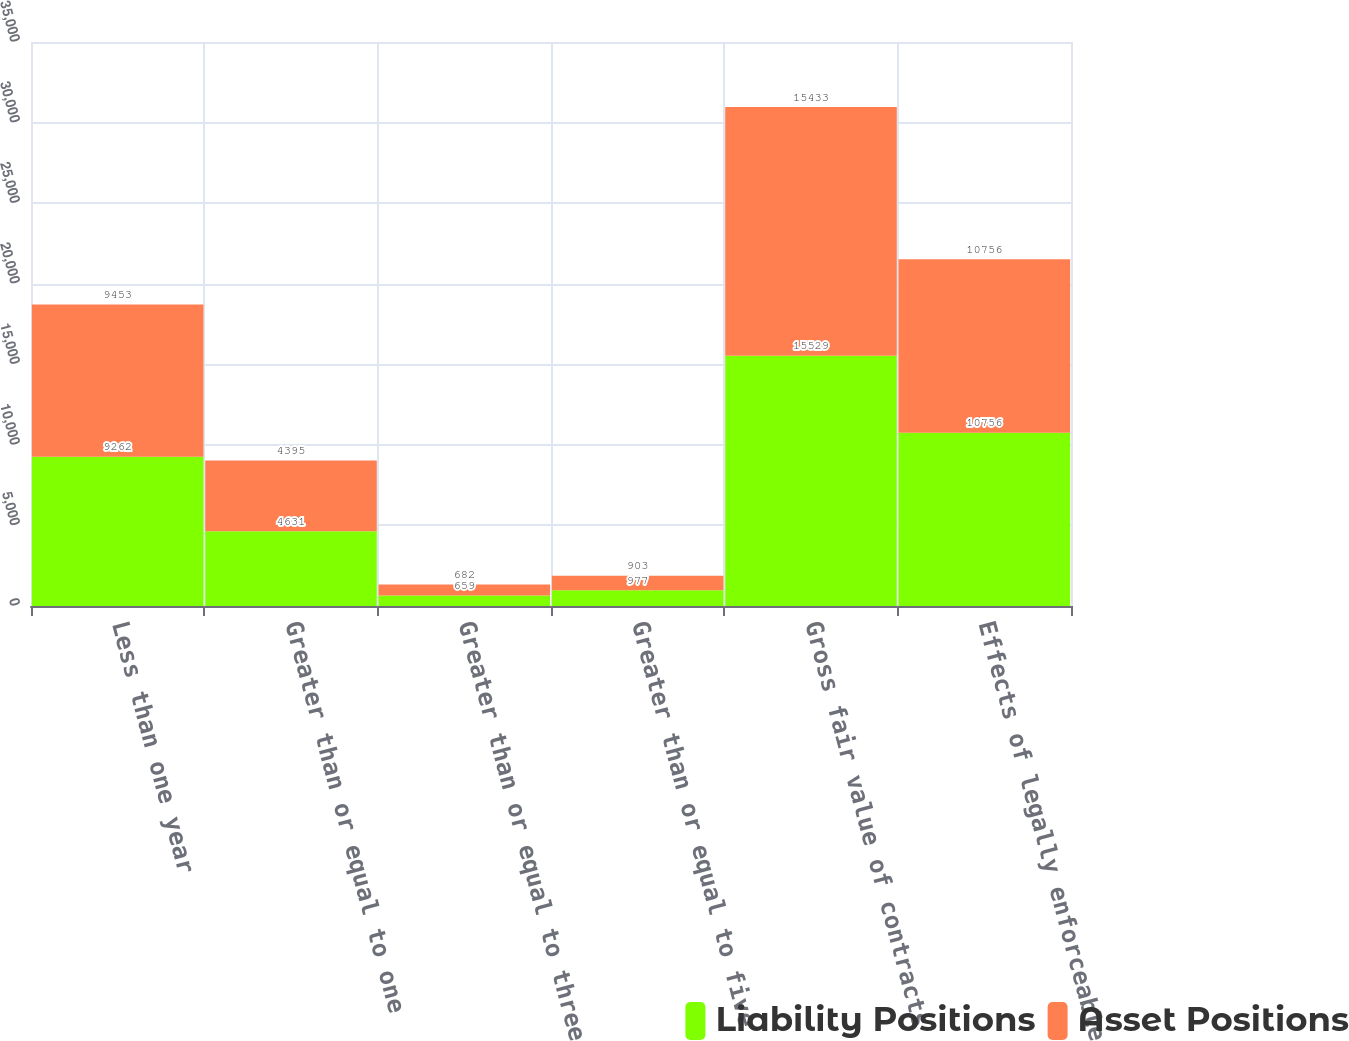Convert chart to OTSL. <chart><loc_0><loc_0><loc_500><loc_500><stacked_bar_chart><ecel><fcel>Less than one year<fcel>Greater than or equal to one<fcel>Greater than or equal to three<fcel>Greater than or equal to five<fcel>Gross fair value of contracts<fcel>Effects of legally enforceable<nl><fcel>Liability Positions<fcel>9262<fcel>4631<fcel>659<fcel>977<fcel>15529<fcel>10756<nl><fcel>Asset Positions<fcel>9453<fcel>4395<fcel>682<fcel>903<fcel>15433<fcel>10756<nl></chart> 